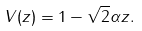<formula> <loc_0><loc_0><loc_500><loc_500>V ( z ) = 1 - \sqrt { 2 } \alpha z .</formula> 